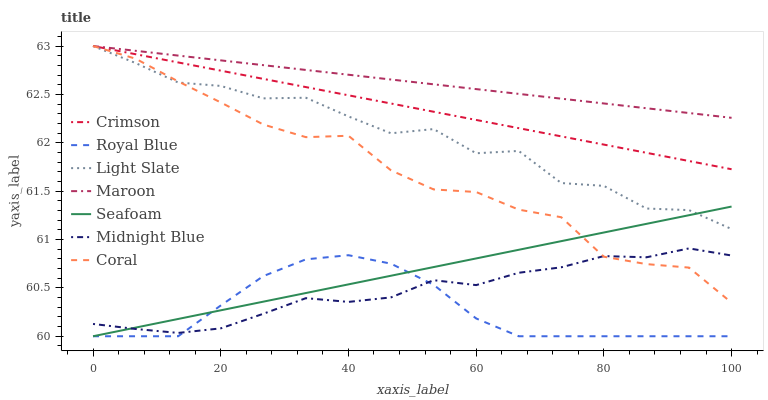Does Royal Blue have the minimum area under the curve?
Answer yes or no. Yes. Does Maroon have the maximum area under the curve?
Answer yes or no. Yes. Does Light Slate have the minimum area under the curve?
Answer yes or no. No. Does Light Slate have the maximum area under the curve?
Answer yes or no. No. Is Crimson the smoothest?
Answer yes or no. Yes. Is Light Slate the roughest?
Answer yes or no. Yes. Is Coral the smoothest?
Answer yes or no. No. Is Coral the roughest?
Answer yes or no. No. Does Seafoam have the lowest value?
Answer yes or no. Yes. Does Light Slate have the lowest value?
Answer yes or no. No. Does Crimson have the highest value?
Answer yes or no. Yes. Does Seafoam have the highest value?
Answer yes or no. No. Is Midnight Blue less than Crimson?
Answer yes or no. Yes. Is Crimson greater than Seafoam?
Answer yes or no. Yes. Does Seafoam intersect Light Slate?
Answer yes or no. Yes. Is Seafoam less than Light Slate?
Answer yes or no. No. Is Seafoam greater than Light Slate?
Answer yes or no. No. Does Midnight Blue intersect Crimson?
Answer yes or no. No. 